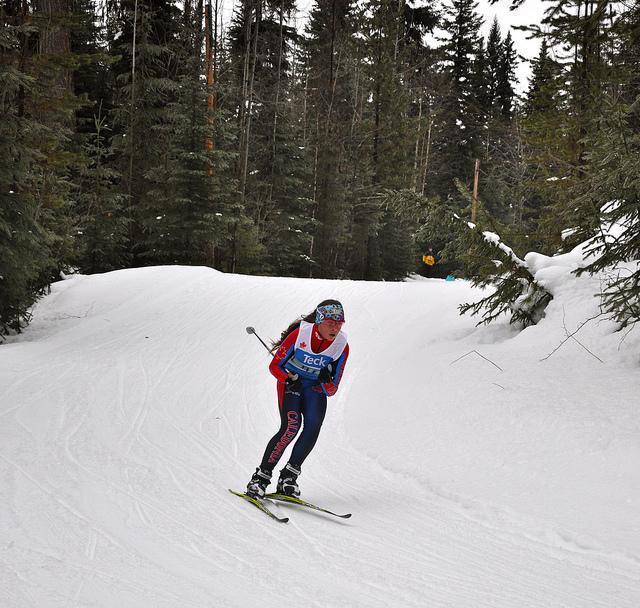How many suitcases are on the floor?
Give a very brief answer. 0. 